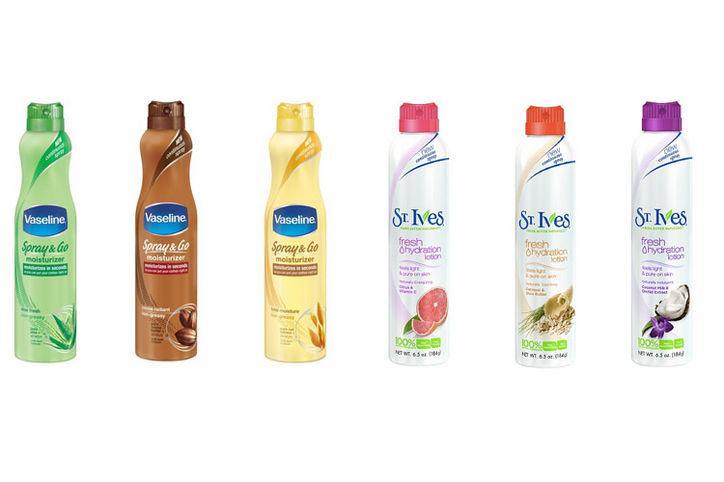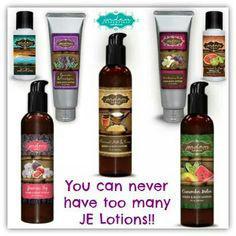The first image is the image on the left, the second image is the image on the right. Evaluate the accuracy of this statement regarding the images: "A grouping of skincare products includes at least one round shallow jar.". Is it true? Answer yes or no. No. 